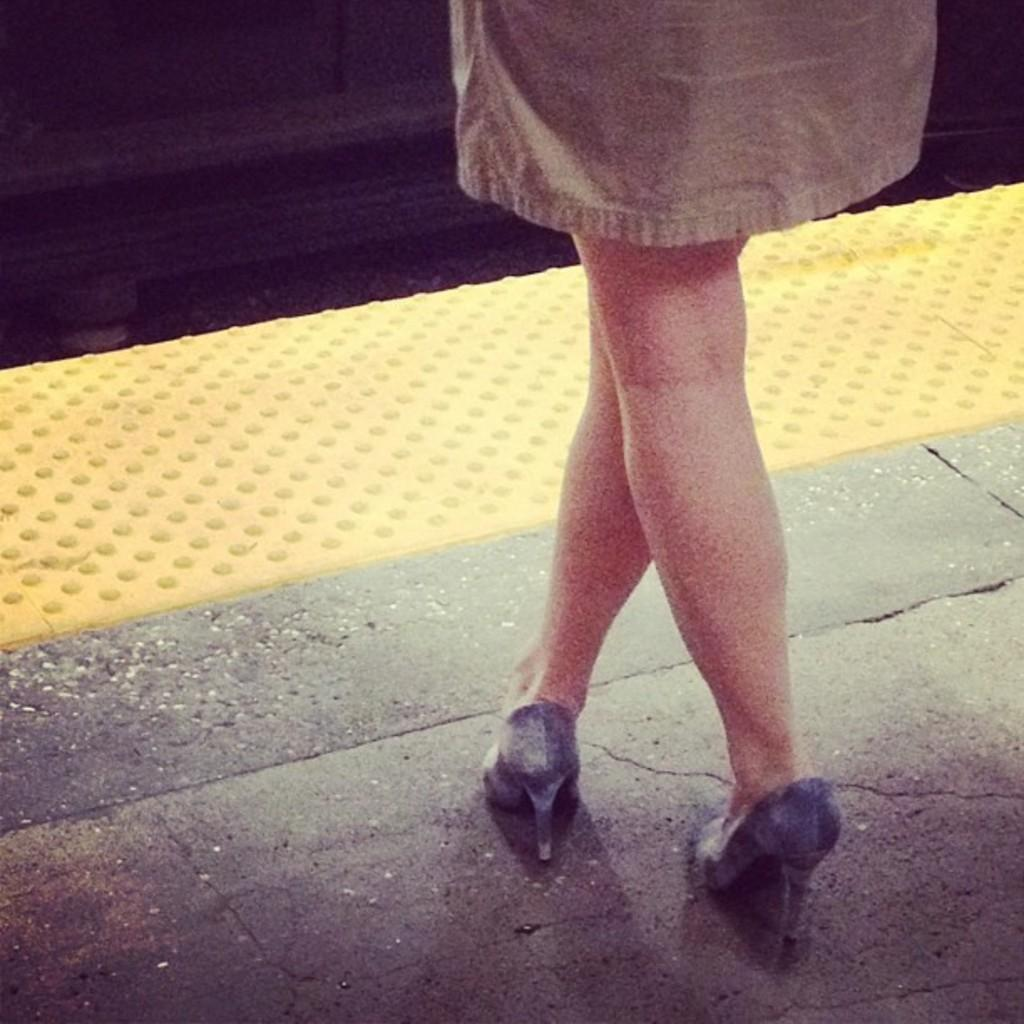What body part is visible in the image? There are legs of a human in the image. What type of clothing is the human wearing on their feet? The human is wearing footwear. How many oranges can be seen in the image? There are no oranges present in the image. What type of fang is visible in the image? There are no fangs present in the image. 